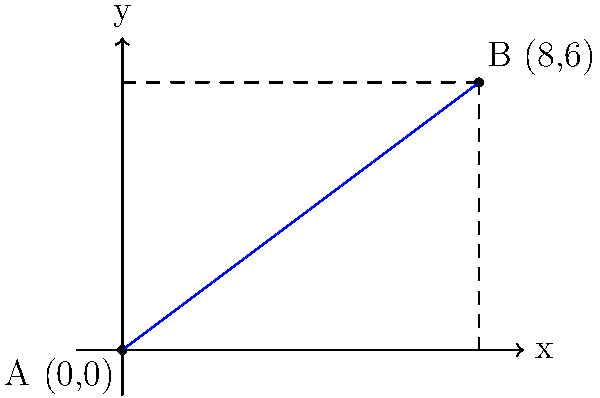On the campus map of Park Prewett Hospital, two buildings are represented by points A(0,0) and B(8,6). As a former nurse who worked at this hospital, you need to calculate the straight-line distance between these two buildings. What is the distance between points A and B? To find the distance between two points, we can use the distance formula derived from the Pythagorean theorem:

$$d = \sqrt{(x_2 - x_1)^2 + (y_2 - y_1)^2}$$

Where $(x_1, y_1)$ are the coordinates of point A and $(x_2, y_2)$ are the coordinates of point B.

Step 1: Identify the coordinates
A: $(x_1, y_1) = (0, 0)$
B: $(x_2, y_2) = (8, 6)$

Step 2: Plug the values into the distance formula
$$d = \sqrt{(8 - 0)^2 + (6 - 0)^2}$$

Step 3: Simplify the expressions inside the parentheses
$$d = \sqrt{8^2 + 6^2}$$

Step 4: Calculate the squares
$$d = \sqrt{64 + 36}$$

Step 5: Add the values under the square root
$$d = \sqrt{100}$$

Step 6: Simplify the square root
$$d = 10$$

Therefore, the distance between the two buildings is 10 units on the map scale.
Answer: 10 units 